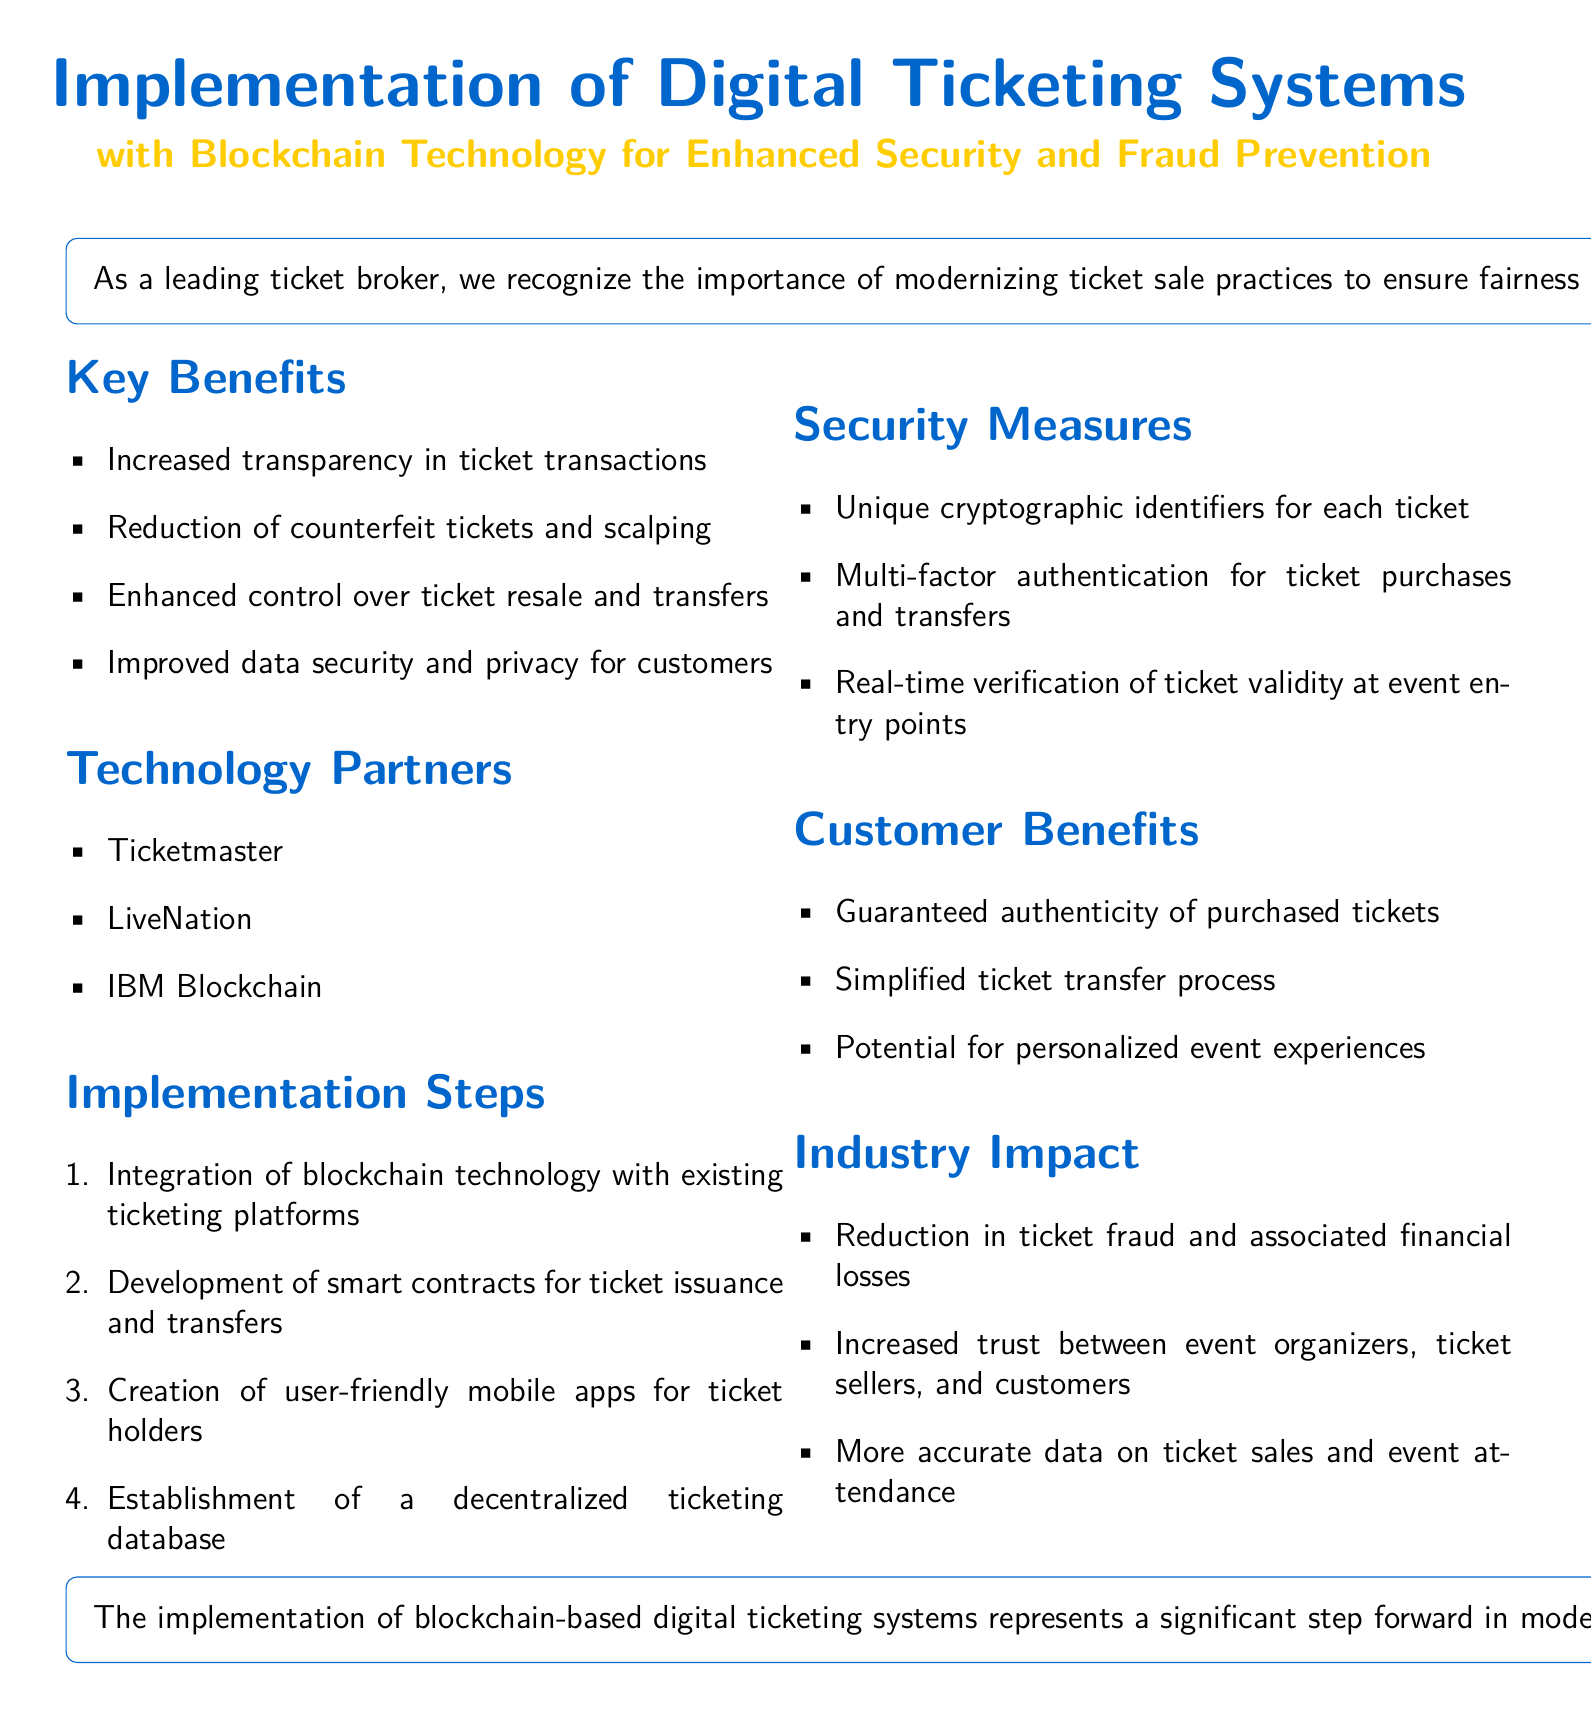What are the key benefits of the digital ticketing system? The key benefits listed in the document include increased transparency, reduction of counterfeit tickets, enhanced control over ticket resale, and improved data security and privacy.
Answer: Increased transparency, reduction of counterfeit tickets, enhanced control over ticket resale, improved data security and privacy Who are the technology partners mentioned? The document specifies Ticketmaster, LiveNation, and IBM Blockchain as the technology partners involved in the implementation.
Answer: Ticketmaster, LiveNation, IBM Blockchain What unique feature is included for ticket security? Unique cryptographic identifiers are mentioned as a key feature to enhance security in ticket transactions.
Answer: Unique cryptographic identifiers How many steps are listed for implementation? The document outlines four steps required for the implementation of the system.
Answer: Four steps What is one customer benefit provided by the system? The document lists guaranteed authenticity of purchased tickets as a benefit for customers using the blockchain-based digital ticketing system.
Answer: Guaranteed authenticity of purchased tickets Which industry impacts are highlighted? The document emphasizes a reduction in ticket fraud, increased trust, and more accurate data on sales and attendance as impacts of the new system.
Answer: Reduction in ticket fraud, increased trust, more accurate data What is the main purpose of this policy document? The primary purpose as stated in the document is to outline the implementation of blockchain-based digital ticketing systems to ensure fairness and security in ticket sales.
Answer: Ensure fairness and security in ticket sales 